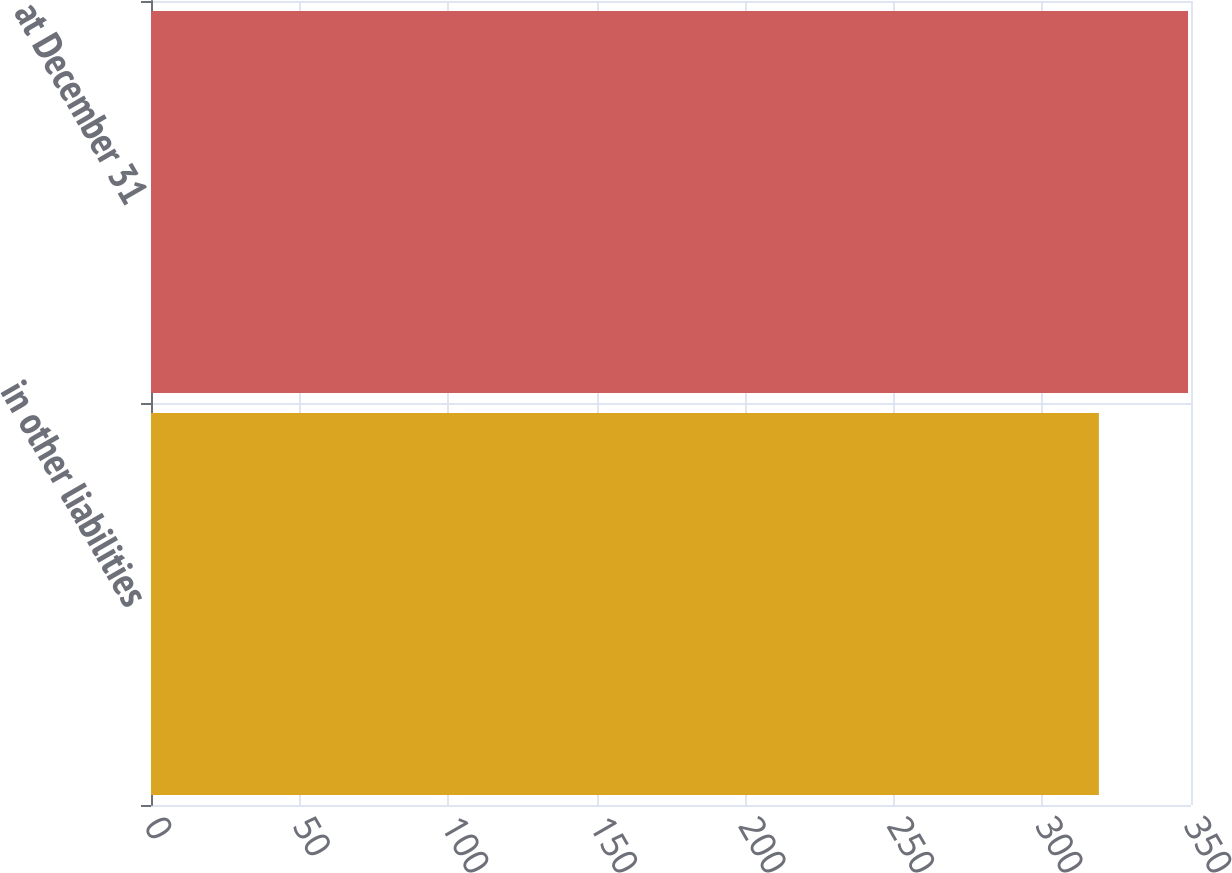Convert chart. <chart><loc_0><loc_0><loc_500><loc_500><bar_chart><fcel>in other liabilities<fcel>at December 31<nl><fcel>319<fcel>349<nl></chart> 